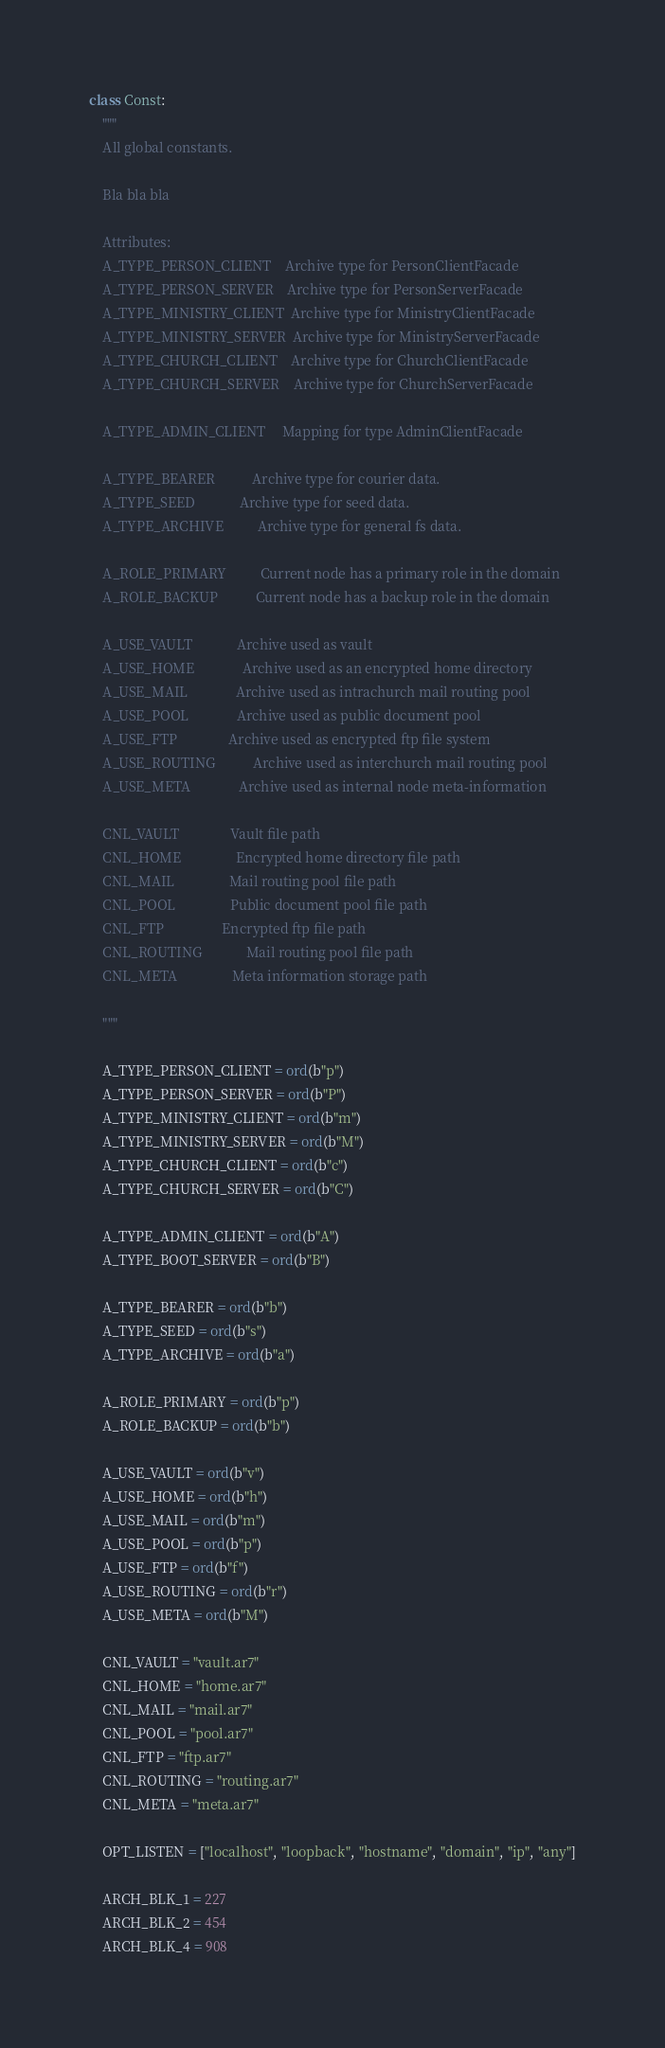Convert code to text. <code><loc_0><loc_0><loc_500><loc_500><_Cython_>

class Const:
    """
    All global constants.

    Bla bla bla

    Attributes:
    A_TYPE_PERSON_CLIENT    Archive type for PersonClientFacade
    A_TYPE_PERSON_SERVER    Archive type for PersonServerFacade
    A_TYPE_MINISTRY_CLIENT  Archive type for MinistryClientFacade
    A_TYPE_MINISTRY_SERVER  Archive type for MinistryServerFacade
    A_TYPE_CHURCH_CLIENT    Archive type for ChurchClientFacade
    A_TYPE_CHURCH_SERVER    Archive type for ChurchServerFacade

    A_TYPE_ADMIN_CLIENT     Mapping for type AdminClientFacade

    A_TYPE_BEARER           Archive type for courier data.
    A_TYPE_SEED             Archive type for seed data.
    A_TYPE_ARCHIVE          Archive type for general fs data.

    A_ROLE_PRIMARY          Current node has a primary role in the domain
    A_ROLE_BACKUP           Current node has a backup role in the domain

    A_USE_VAULT             Archive used as vault
    A_USE_HOME              Archive used as an encrypted home directory
    A_USE_MAIL              Archive used as intrachurch mail routing pool
    A_USE_POOL              Archive used as public document pool
    A_USE_FTP               Archive used as encrypted ftp file system
    A_USE_ROUTING           Archive used as interchurch mail routing pool
    A_USE_META              Archive used as internal node meta-information

    CNL_VAULT               Vault file path
    CNL_HOME                Encrypted home directory file path
    CNL_MAIL                Mail routing pool file path
    CNL_POOL                Public document pool file path
    CNL_FTP                 Encrypted ftp file path
    CNL_ROUTING             Mail routing pool file path
    CNL_META                Meta information storage path

    """

    A_TYPE_PERSON_CLIENT = ord(b"p")
    A_TYPE_PERSON_SERVER = ord(b"P")
    A_TYPE_MINISTRY_CLIENT = ord(b"m")
    A_TYPE_MINISTRY_SERVER = ord(b"M")
    A_TYPE_CHURCH_CLIENT = ord(b"c")
    A_TYPE_CHURCH_SERVER = ord(b"C")

    A_TYPE_ADMIN_CLIENT = ord(b"A")
    A_TYPE_BOOT_SERVER = ord(b"B")

    A_TYPE_BEARER = ord(b"b")
    A_TYPE_SEED = ord(b"s")
    A_TYPE_ARCHIVE = ord(b"a")

    A_ROLE_PRIMARY = ord(b"p")
    A_ROLE_BACKUP = ord(b"b")

    A_USE_VAULT = ord(b"v")
    A_USE_HOME = ord(b"h")
    A_USE_MAIL = ord(b"m")
    A_USE_POOL = ord(b"p")
    A_USE_FTP = ord(b"f")
    A_USE_ROUTING = ord(b"r")
    A_USE_META = ord(b"M")

    CNL_VAULT = "vault.ar7"
    CNL_HOME = "home.ar7"
    CNL_MAIL = "mail.ar7"
    CNL_POOL = "pool.ar7"
    CNL_FTP = "ftp.ar7"
    CNL_ROUTING = "routing.ar7"
    CNL_META = "meta.ar7"

    OPT_LISTEN = ["localhost", "loopback", "hostname", "domain", "ip", "any"]

    ARCH_BLK_1 = 227
    ARCH_BLK_2 = 454
    ARCH_BLK_4 = 908
</code> 